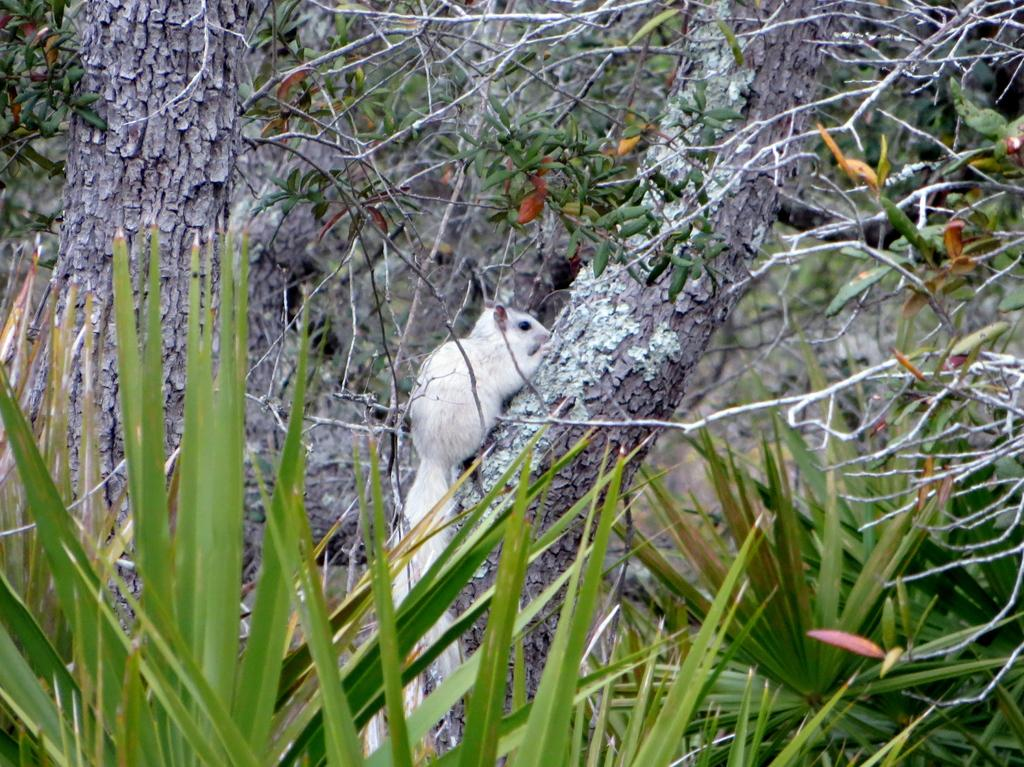What type of animal can be seen in the image? There is an animal in the image, but its specific type cannot be determined from the provided facts. What color is the animal in the image? The animal is white in color. Where is the animal located in the image? The animal is on a tree trunk. What other elements are present in the image besides the animal? There are plants in the image. How would you describe the background of the image? The background of the image is blurred. What type of hope can be seen in the image? There is no reference to hope in the image, so it cannot be determined from the provided facts. 